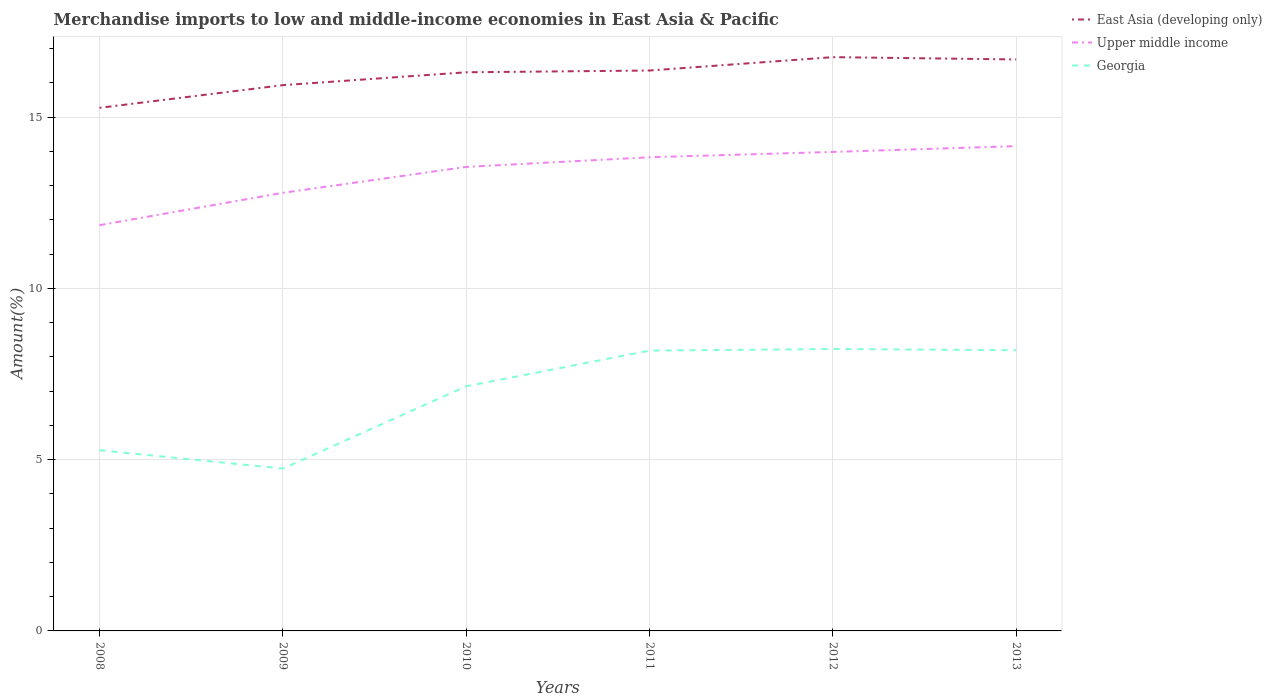Does the line corresponding to Upper middle income intersect with the line corresponding to Georgia?
Offer a very short reply. No. Across all years, what is the maximum percentage of amount earned from merchandise imports in Upper middle income?
Your response must be concise. 11.85. What is the total percentage of amount earned from merchandise imports in East Asia (developing only) in the graph?
Ensure brevity in your answer.  -0.38. What is the difference between the highest and the second highest percentage of amount earned from merchandise imports in Georgia?
Your answer should be compact. 3.49. What is the difference between the highest and the lowest percentage of amount earned from merchandise imports in Georgia?
Keep it short and to the point. 4. How many lines are there?
Provide a succinct answer. 3. Does the graph contain grids?
Offer a very short reply. Yes. Where does the legend appear in the graph?
Keep it short and to the point. Top right. How many legend labels are there?
Your answer should be compact. 3. How are the legend labels stacked?
Provide a short and direct response. Vertical. What is the title of the graph?
Your answer should be compact. Merchandise imports to low and middle-income economies in East Asia & Pacific. What is the label or title of the X-axis?
Keep it short and to the point. Years. What is the label or title of the Y-axis?
Provide a short and direct response. Amount(%). What is the Amount(%) of East Asia (developing only) in 2008?
Offer a terse response. 15.27. What is the Amount(%) in Upper middle income in 2008?
Keep it short and to the point. 11.85. What is the Amount(%) of Georgia in 2008?
Make the answer very short. 5.28. What is the Amount(%) of East Asia (developing only) in 2009?
Your answer should be compact. 15.93. What is the Amount(%) in Upper middle income in 2009?
Give a very brief answer. 12.79. What is the Amount(%) of Georgia in 2009?
Offer a very short reply. 4.74. What is the Amount(%) of East Asia (developing only) in 2010?
Make the answer very short. 16.31. What is the Amount(%) of Upper middle income in 2010?
Your answer should be very brief. 13.55. What is the Amount(%) of Georgia in 2010?
Make the answer very short. 7.14. What is the Amount(%) of East Asia (developing only) in 2011?
Ensure brevity in your answer.  16.36. What is the Amount(%) of Upper middle income in 2011?
Make the answer very short. 13.83. What is the Amount(%) in Georgia in 2011?
Your answer should be very brief. 8.18. What is the Amount(%) in East Asia (developing only) in 2012?
Keep it short and to the point. 16.75. What is the Amount(%) of Upper middle income in 2012?
Offer a very short reply. 13.98. What is the Amount(%) in Georgia in 2012?
Offer a terse response. 8.23. What is the Amount(%) in East Asia (developing only) in 2013?
Ensure brevity in your answer.  16.68. What is the Amount(%) of Upper middle income in 2013?
Your answer should be compact. 14.15. What is the Amount(%) in Georgia in 2013?
Provide a succinct answer. 8.2. Across all years, what is the maximum Amount(%) in East Asia (developing only)?
Provide a short and direct response. 16.75. Across all years, what is the maximum Amount(%) of Upper middle income?
Your response must be concise. 14.15. Across all years, what is the maximum Amount(%) of Georgia?
Your answer should be very brief. 8.23. Across all years, what is the minimum Amount(%) in East Asia (developing only)?
Give a very brief answer. 15.27. Across all years, what is the minimum Amount(%) in Upper middle income?
Give a very brief answer. 11.85. Across all years, what is the minimum Amount(%) in Georgia?
Provide a short and direct response. 4.74. What is the total Amount(%) of East Asia (developing only) in the graph?
Provide a succinct answer. 97.31. What is the total Amount(%) in Upper middle income in the graph?
Your answer should be compact. 80.15. What is the total Amount(%) of Georgia in the graph?
Your response must be concise. 41.77. What is the difference between the Amount(%) in East Asia (developing only) in 2008 and that in 2009?
Make the answer very short. -0.66. What is the difference between the Amount(%) in Upper middle income in 2008 and that in 2009?
Your answer should be very brief. -0.94. What is the difference between the Amount(%) of Georgia in 2008 and that in 2009?
Provide a short and direct response. 0.54. What is the difference between the Amount(%) of East Asia (developing only) in 2008 and that in 2010?
Make the answer very short. -1.04. What is the difference between the Amount(%) in Upper middle income in 2008 and that in 2010?
Your response must be concise. -1.7. What is the difference between the Amount(%) in Georgia in 2008 and that in 2010?
Ensure brevity in your answer.  -1.87. What is the difference between the Amount(%) in East Asia (developing only) in 2008 and that in 2011?
Offer a very short reply. -1.09. What is the difference between the Amount(%) in Upper middle income in 2008 and that in 2011?
Your answer should be compact. -1.98. What is the difference between the Amount(%) of Georgia in 2008 and that in 2011?
Offer a very short reply. -2.91. What is the difference between the Amount(%) in East Asia (developing only) in 2008 and that in 2012?
Your response must be concise. -1.48. What is the difference between the Amount(%) of Upper middle income in 2008 and that in 2012?
Provide a short and direct response. -2.14. What is the difference between the Amount(%) in Georgia in 2008 and that in 2012?
Make the answer very short. -2.96. What is the difference between the Amount(%) of East Asia (developing only) in 2008 and that in 2013?
Offer a very short reply. -1.41. What is the difference between the Amount(%) in Upper middle income in 2008 and that in 2013?
Your response must be concise. -2.31. What is the difference between the Amount(%) of Georgia in 2008 and that in 2013?
Your response must be concise. -2.92. What is the difference between the Amount(%) in East Asia (developing only) in 2009 and that in 2010?
Offer a very short reply. -0.38. What is the difference between the Amount(%) in Upper middle income in 2009 and that in 2010?
Ensure brevity in your answer.  -0.76. What is the difference between the Amount(%) of Georgia in 2009 and that in 2010?
Make the answer very short. -2.4. What is the difference between the Amount(%) in East Asia (developing only) in 2009 and that in 2011?
Keep it short and to the point. -0.43. What is the difference between the Amount(%) in Upper middle income in 2009 and that in 2011?
Your response must be concise. -1.04. What is the difference between the Amount(%) of Georgia in 2009 and that in 2011?
Offer a very short reply. -3.44. What is the difference between the Amount(%) in East Asia (developing only) in 2009 and that in 2012?
Your answer should be very brief. -0.82. What is the difference between the Amount(%) in Upper middle income in 2009 and that in 2012?
Keep it short and to the point. -1.19. What is the difference between the Amount(%) of Georgia in 2009 and that in 2012?
Ensure brevity in your answer.  -3.49. What is the difference between the Amount(%) in East Asia (developing only) in 2009 and that in 2013?
Your answer should be compact. -0.75. What is the difference between the Amount(%) of Upper middle income in 2009 and that in 2013?
Give a very brief answer. -1.36. What is the difference between the Amount(%) in Georgia in 2009 and that in 2013?
Provide a succinct answer. -3.46. What is the difference between the Amount(%) of East Asia (developing only) in 2010 and that in 2011?
Ensure brevity in your answer.  -0.05. What is the difference between the Amount(%) in Upper middle income in 2010 and that in 2011?
Provide a short and direct response. -0.28. What is the difference between the Amount(%) in Georgia in 2010 and that in 2011?
Keep it short and to the point. -1.04. What is the difference between the Amount(%) in East Asia (developing only) in 2010 and that in 2012?
Your answer should be very brief. -0.44. What is the difference between the Amount(%) of Upper middle income in 2010 and that in 2012?
Your answer should be very brief. -0.44. What is the difference between the Amount(%) in Georgia in 2010 and that in 2012?
Provide a short and direct response. -1.09. What is the difference between the Amount(%) in East Asia (developing only) in 2010 and that in 2013?
Give a very brief answer. -0.37. What is the difference between the Amount(%) of Upper middle income in 2010 and that in 2013?
Provide a succinct answer. -0.61. What is the difference between the Amount(%) of Georgia in 2010 and that in 2013?
Keep it short and to the point. -1.05. What is the difference between the Amount(%) of East Asia (developing only) in 2011 and that in 2012?
Offer a very short reply. -0.39. What is the difference between the Amount(%) of Upper middle income in 2011 and that in 2012?
Make the answer very short. -0.15. What is the difference between the Amount(%) of Georgia in 2011 and that in 2012?
Offer a terse response. -0.05. What is the difference between the Amount(%) of East Asia (developing only) in 2011 and that in 2013?
Offer a very short reply. -0.32. What is the difference between the Amount(%) in Upper middle income in 2011 and that in 2013?
Give a very brief answer. -0.32. What is the difference between the Amount(%) of Georgia in 2011 and that in 2013?
Offer a terse response. -0.01. What is the difference between the Amount(%) of East Asia (developing only) in 2012 and that in 2013?
Make the answer very short. 0.07. What is the difference between the Amount(%) of Upper middle income in 2012 and that in 2013?
Ensure brevity in your answer.  -0.17. What is the difference between the Amount(%) of Georgia in 2012 and that in 2013?
Your response must be concise. 0.03. What is the difference between the Amount(%) of East Asia (developing only) in 2008 and the Amount(%) of Upper middle income in 2009?
Offer a terse response. 2.48. What is the difference between the Amount(%) of East Asia (developing only) in 2008 and the Amount(%) of Georgia in 2009?
Provide a succinct answer. 10.53. What is the difference between the Amount(%) in Upper middle income in 2008 and the Amount(%) in Georgia in 2009?
Your answer should be very brief. 7.11. What is the difference between the Amount(%) in East Asia (developing only) in 2008 and the Amount(%) in Upper middle income in 2010?
Ensure brevity in your answer.  1.72. What is the difference between the Amount(%) in East Asia (developing only) in 2008 and the Amount(%) in Georgia in 2010?
Give a very brief answer. 8.13. What is the difference between the Amount(%) of Upper middle income in 2008 and the Amount(%) of Georgia in 2010?
Make the answer very short. 4.7. What is the difference between the Amount(%) of East Asia (developing only) in 2008 and the Amount(%) of Upper middle income in 2011?
Ensure brevity in your answer.  1.44. What is the difference between the Amount(%) in East Asia (developing only) in 2008 and the Amount(%) in Georgia in 2011?
Provide a short and direct response. 7.09. What is the difference between the Amount(%) of Upper middle income in 2008 and the Amount(%) of Georgia in 2011?
Provide a succinct answer. 3.66. What is the difference between the Amount(%) in East Asia (developing only) in 2008 and the Amount(%) in Upper middle income in 2012?
Give a very brief answer. 1.29. What is the difference between the Amount(%) of East Asia (developing only) in 2008 and the Amount(%) of Georgia in 2012?
Your answer should be very brief. 7.04. What is the difference between the Amount(%) of Upper middle income in 2008 and the Amount(%) of Georgia in 2012?
Your answer should be very brief. 3.62. What is the difference between the Amount(%) of East Asia (developing only) in 2008 and the Amount(%) of Upper middle income in 2013?
Your answer should be very brief. 1.12. What is the difference between the Amount(%) in East Asia (developing only) in 2008 and the Amount(%) in Georgia in 2013?
Keep it short and to the point. 7.07. What is the difference between the Amount(%) in Upper middle income in 2008 and the Amount(%) in Georgia in 2013?
Keep it short and to the point. 3.65. What is the difference between the Amount(%) of East Asia (developing only) in 2009 and the Amount(%) of Upper middle income in 2010?
Ensure brevity in your answer.  2.39. What is the difference between the Amount(%) of East Asia (developing only) in 2009 and the Amount(%) of Georgia in 2010?
Provide a succinct answer. 8.79. What is the difference between the Amount(%) in Upper middle income in 2009 and the Amount(%) in Georgia in 2010?
Offer a terse response. 5.65. What is the difference between the Amount(%) of East Asia (developing only) in 2009 and the Amount(%) of Upper middle income in 2011?
Give a very brief answer. 2.1. What is the difference between the Amount(%) in East Asia (developing only) in 2009 and the Amount(%) in Georgia in 2011?
Provide a succinct answer. 7.75. What is the difference between the Amount(%) of Upper middle income in 2009 and the Amount(%) of Georgia in 2011?
Make the answer very short. 4.61. What is the difference between the Amount(%) in East Asia (developing only) in 2009 and the Amount(%) in Upper middle income in 2012?
Keep it short and to the point. 1.95. What is the difference between the Amount(%) of East Asia (developing only) in 2009 and the Amount(%) of Georgia in 2012?
Provide a succinct answer. 7.7. What is the difference between the Amount(%) of Upper middle income in 2009 and the Amount(%) of Georgia in 2012?
Offer a terse response. 4.56. What is the difference between the Amount(%) of East Asia (developing only) in 2009 and the Amount(%) of Upper middle income in 2013?
Offer a terse response. 1.78. What is the difference between the Amount(%) of East Asia (developing only) in 2009 and the Amount(%) of Georgia in 2013?
Provide a succinct answer. 7.74. What is the difference between the Amount(%) of Upper middle income in 2009 and the Amount(%) of Georgia in 2013?
Keep it short and to the point. 4.59. What is the difference between the Amount(%) of East Asia (developing only) in 2010 and the Amount(%) of Upper middle income in 2011?
Make the answer very short. 2.48. What is the difference between the Amount(%) in East Asia (developing only) in 2010 and the Amount(%) in Georgia in 2011?
Offer a terse response. 8.13. What is the difference between the Amount(%) in Upper middle income in 2010 and the Amount(%) in Georgia in 2011?
Make the answer very short. 5.36. What is the difference between the Amount(%) in East Asia (developing only) in 2010 and the Amount(%) in Upper middle income in 2012?
Provide a short and direct response. 2.33. What is the difference between the Amount(%) in East Asia (developing only) in 2010 and the Amount(%) in Georgia in 2012?
Provide a succinct answer. 8.08. What is the difference between the Amount(%) of Upper middle income in 2010 and the Amount(%) of Georgia in 2012?
Offer a very short reply. 5.32. What is the difference between the Amount(%) of East Asia (developing only) in 2010 and the Amount(%) of Upper middle income in 2013?
Make the answer very short. 2.16. What is the difference between the Amount(%) of East Asia (developing only) in 2010 and the Amount(%) of Georgia in 2013?
Provide a short and direct response. 8.11. What is the difference between the Amount(%) of Upper middle income in 2010 and the Amount(%) of Georgia in 2013?
Your answer should be very brief. 5.35. What is the difference between the Amount(%) of East Asia (developing only) in 2011 and the Amount(%) of Upper middle income in 2012?
Make the answer very short. 2.38. What is the difference between the Amount(%) of East Asia (developing only) in 2011 and the Amount(%) of Georgia in 2012?
Provide a short and direct response. 8.13. What is the difference between the Amount(%) of Upper middle income in 2011 and the Amount(%) of Georgia in 2012?
Ensure brevity in your answer.  5.6. What is the difference between the Amount(%) in East Asia (developing only) in 2011 and the Amount(%) in Upper middle income in 2013?
Your answer should be compact. 2.21. What is the difference between the Amount(%) of East Asia (developing only) in 2011 and the Amount(%) of Georgia in 2013?
Your response must be concise. 8.16. What is the difference between the Amount(%) in Upper middle income in 2011 and the Amount(%) in Georgia in 2013?
Make the answer very short. 5.63. What is the difference between the Amount(%) in East Asia (developing only) in 2012 and the Amount(%) in Upper middle income in 2013?
Provide a succinct answer. 2.6. What is the difference between the Amount(%) of East Asia (developing only) in 2012 and the Amount(%) of Georgia in 2013?
Keep it short and to the point. 8.55. What is the difference between the Amount(%) in Upper middle income in 2012 and the Amount(%) in Georgia in 2013?
Your answer should be compact. 5.79. What is the average Amount(%) of East Asia (developing only) per year?
Give a very brief answer. 16.22. What is the average Amount(%) of Upper middle income per year?
Keep it short and to the point. 13.36. What is the average Amount(%) in Georgia per year?
Offer a terse response. 6.96. In the year 2008, what is the difference between the Amount(%) in East Asia (developing only) and Amount(%) in Upper middle income?
Offer a very short reply. 3.43. In the year 2008, what is the difference between the Amount(%) of East Asia (developing only) and Amount(%) of Georgia?
Your answer should be compact. 10. In the year 2008, what is the difference between the Amount(%) of Upper middle income and Amount(%) of Georgia?
Your answer should be compact. 6.57. In the year 2009, what is the difference between the Amount(%) in East Asia (developing only) and Amount(%) in Upper middle income?
Make the answer very short. 3.14. In the year 2009, what is the difference between the Amount(%) in East Asia (developing only) and Amount(%) in Georgia?
Give a very brief answer. 11.19. In the year 2009, what is the difference between the Amount(%) in Upper middle income and Amount(%) in Georgia?
Offer a very short reply. 8.05. In the year 2010, what is the difference between the Amount(%) of East Asia (developing only) and Amount(%) of Upper middle income?
Offer a very short reply. 2.76. In the year 2010, what is the difference between the Amount(%) of East Asia (developing only) and Amount(%) of Georgia?
Offer a very short reply. 9.17. In the year 2010, what is the difference between the Amount(%) of Upper middle income and Amount(%) of Georgia?
Provide a short and direct response. 6.4. In the year 2011, what is the difference between the Amount(%) of East Asia (developing only) and Amount(%) of Upper middle income?
Give a very brief answer. 2.53. In the year 2011, what is the difference between the Amount(%) in East Asia (developing only) and Amount(%) in Georgia?
Your answer should be very brief. 8.18. In the year 2011, what is the difference between the Amount(%) of Upper middle income and Amount(%) of Georgia?
Ensure brevity in your answer.  5.65. In the year 2012, what is the difference between the Amount(%) in East Asia (developing only) and Amount(%) in Upper middle income?
Your answer should be compact. 2.77. In the year 2012, what is the difference between the Amount(%) of East Asia (developing only) and Amount(%) of Georgia?
Your answer should be compact. 8.52. In the year 2012, what is the difference between the Amount(%) in Upper middle income and Amount(%) in Georgia?
Your answer should be very brief. 5.75. In the year 2013, what is the difference between the Amount(%) of East Asia (developing only) and Amount(%) of Upper middle income?
Give a very brief answer. 2.53. In the year 2013, what is the difference between the Amount(%) in East Asia (developing only) and Amount(%) in Georgia?
Your response must be concise. 8.49. In the year 2013, what is the difference between the Amount(%) in Upper middle income and Amount(%) in Georgia?
Keep it short and to the point. 5.96. What is the ratio of the Amount(%) of East Asia (developing only) in 2008 to that in 2009?
Offer a terse response. 0.96. What is the ratio of the Amount(%) of Upper middle income in 2008 to that in 2009?
Your response must be concise. 0.93. What is the ratio of the Amount(%) of Georgia in 2008 to that in 2009?
Make the answer very short. 1.11. What is the ratio of the Amount(%) of East Asia (developing only) in 2008 to that in 2010?
Provide a succinct answer. 0.94. What is the ratio of the Amount(%) in Upper middle income in 2008 to that in 2010?
Offer a terse response. 0.87. What is the ratio of the Amount(%) in Georgia in 2008 to that in 2010?
Provide a short and direct response. 0.74. What is the ratio of the Amount(%) in East Asia (developing only) in 2008 to that in 2011?
Offer a terse response. 0.93. What is the ratio of the Amount(%) of Upper middle income in 2008 to that in 2011?
Offer a very short reply. 0.86. What is the ratio of the Amount(%) in Georgia in 2008 to that in 2011?
Provide a short and direct response. 0.64. What is the ratio of the Amount(%) in East Asia (developing only) in 2008 to that in 2012?
Provide a succinct answer. 0.91. What is the ratio of the Amount(%) of Upper middle income in 2008 to that in 2012?
Your response must be concise. 0.85. What is the ratio of the Amount(%) in Georgia in 2008 to that in 2012?
Keep it short and to the point. 0.64. What is the ratio of the Amount(%) of East Asia (developing only) in 2008 to that in 2013?
Give a very brief answer. 0.92. What is the ratio of the Amount(%) of Upper middle income in 2008 to that in 2013?
Give a very brief answer. 0.84. What is the ratio of the Amount(%) of Georgia in 2008 to that in 2013?
Offer a very short reply. 0.64. What is the ratio of the Amount(%) of East Asia (developing only) in 2009 to that in 2010?
Ensure brevity in your answer.  0.98. What is the ratio of the Amount(%) of Upper middle income in 2009 to that in 2010?
Your answer should be compact. 0.94. What is the ratio of the Amount(%) in Georgia in 2009 to that in 2010?
Give a very brief answer. 0.66. What is the ratio of the Amount(%) of East Asia (developing only) in 2009 to that in 2011?
Give a very brief answer. 0.97. What is the ratio of the Amount(%) of Upper middle income in 2009 to that in 2011?
Provide a short and direct response. 0.92. What is the ratio of the Amount(%) in Georgia in 2009 to that in 2011?
Your answer should be compact. 0.58. What is the ratio of the Amount(%) in East Asia (developing only) in 2009 to that in 2012?
Your answer should be very brief. 0.95. What is the ratio of the Amount(%) of Upper middle income in 2009 to that in 2012?
Your response must be concise. 0.91. What is the ratio of the Amount(%) of Georgia in 2009 to that in 2012?
Offer a terse response. 0.58. What is the ratio of the Amount(%) of East Asia (developing only) in 2009 to that in 2013?
Your answer should be compact. 0.95. What is the ratio of the Amount(%) of Upper middle income in 2009 to that in 2013?
Make the answer very short. 0.9. What is the ratio of the Amount(%) of Georgia in 2009 to that in 2013?
Give a very brief answer. 0.58. What is the ratio of the Amount(%) in Upper middle income in 2010 to that in 2011?
Make the answer very short. 0.98. What is the ratio of the Amount(%) of Georgia in 2010 to that in 2011?
Your response must be concise. 0.87. What is the ratio of the Amount(%) in East Asia (developing only) in 2010 to that in 2012?
Make the answer very short. 0.97. What is the ratio of the Amount(%) in Upper middle income in 2010 to that in 2012?
Offer a terse response. 0.97. What is the ratio of the Amount(%) of Georgia in 2010 to that in 2012?
Make the answer very short. 0.87. What is the ratio of the Amount(%) of East Asia (developing only) in 2010 to that in 2013?
Keep it short and to the point. 0.98. What is the ratio of the Amount(%) in Upper middle income in 2010 to that in 2013?
Give a very brief answer. 0.96. What is the ratio of the Amount(%) in Georgia in 2010 to that in 2013?
Make the answer very short. 0.87. What is the ratio of the Amount(%) in East Asia (developing only) in 2011 to that in 2012?
Offer a very short reply. 0.98. What is the ratio of the Amount(%) of Upper middle income in 2011 to that in 2012?
Your answer should be very brief. 0.99. What is the ratio of the Amount(%) of Georgia in 2011 to that in 2012?
Give a very brief answer. 0.99. What is the ratio of the Amount(%) of East Asia (developing only) in 2011 to that in 2013?
Give a very brief answer. 0.98. What is the ratio of the Amount(%) of Upper middle income in 2011 to that in 2013?
Give a very brief answer. 0.98. What is the ratio of the Amount(%) of Georgia in 2011 to that in 2013?
Give a very brief answer. 1. What is the ratio of the Amount(%) in East Asia (developing only) in 2012 to that in 2013?
Keep it short and to the point. 1. What is the ratio of the Amount(%) in Upper middle income in 2012 to that in 2013?
Your answer should be compact. 0.99. What is the ratio of the Amount(%) in Georgia in 2012 to that in 2013?
Your answer should be very brief. 1. What is the difference between the highest and the second highest Amount(%) of East Asia (developing only)?
Your answer should be compact. 0.07. What is the difference between the highest and the second highest Amount(%) of Upper middle income?
Provide a short and direct response. 0.17. What is the difference between the highest and the second highest Amount(%) in Georgia?
Keep it short and to the point. 0.03. What is the difference between the highest and the lowest Amount(%) in East Asia (developing only)?
Offer a terse response. 1.48. What is the difference between the highest and the lowest Amount(%) of Upper middle income?
Ensure brevity in your answer.  2.31. What is the difference between the highest and the lowest Amount(%) in Georgia?
Ensure brevity in your answer.  3.49. 